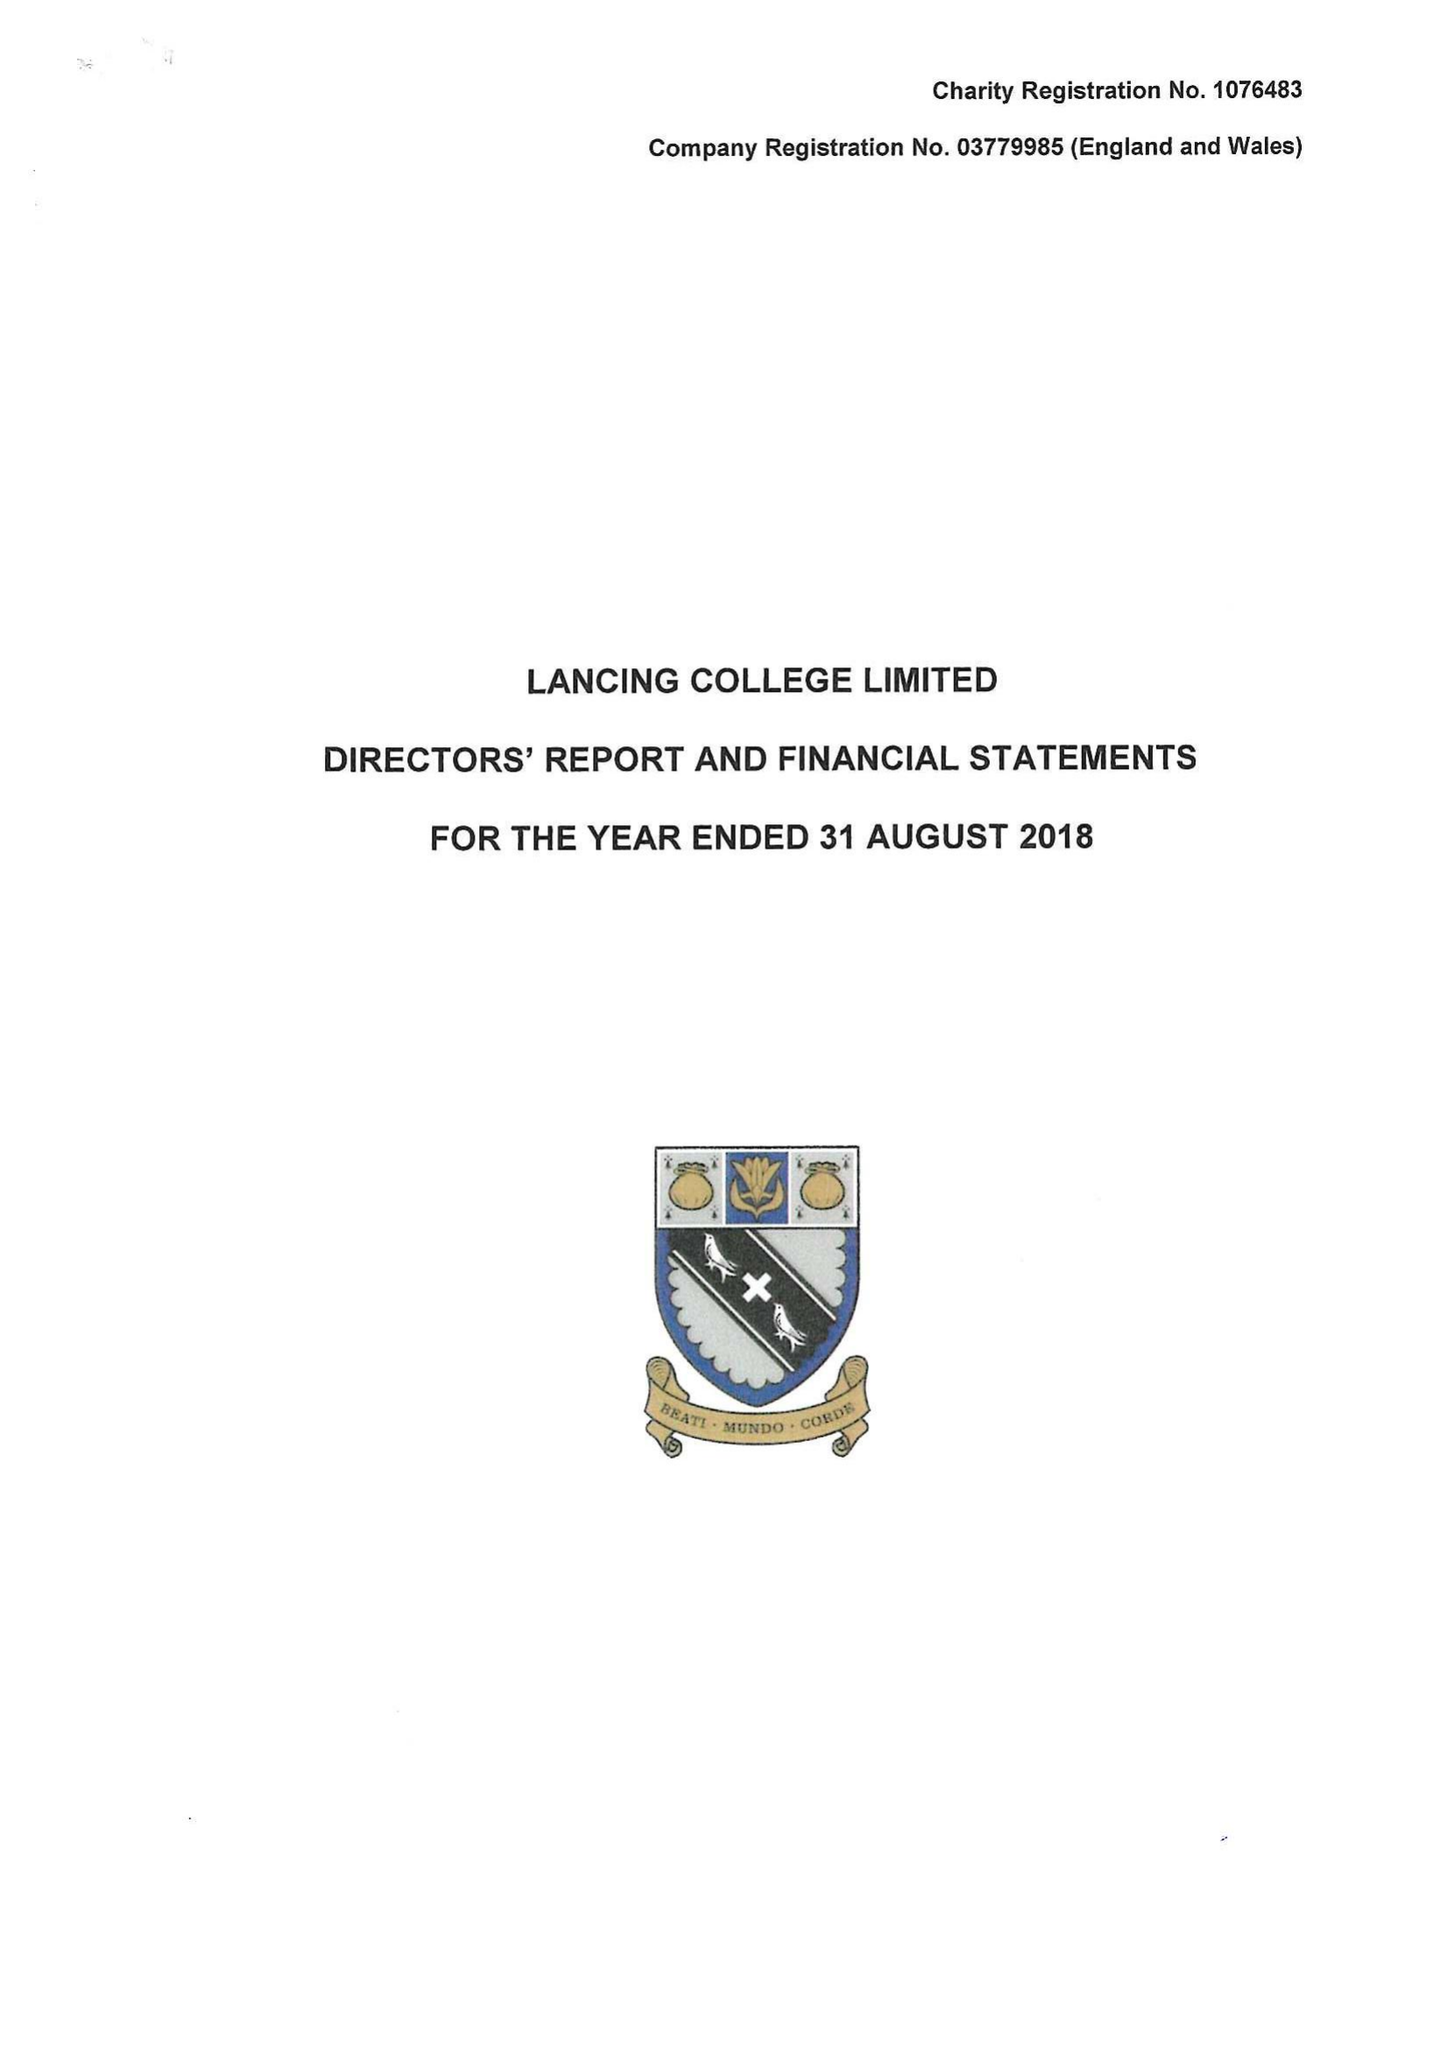What is the value for the charity_number?
Answer the question using a single word or phrase. 1076483 